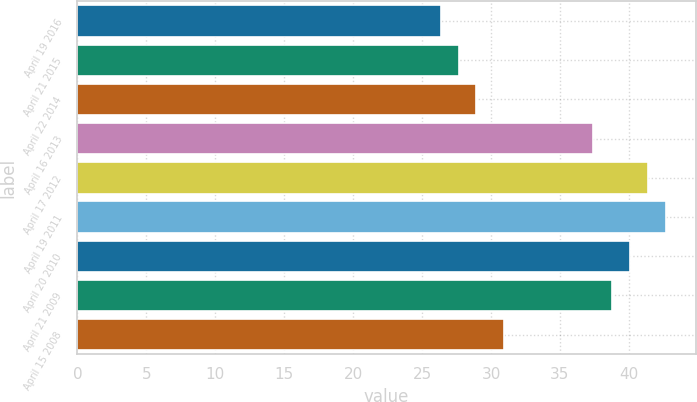Convert chart to OTSL. <chart><loc_0><loc_0><loc_500><loc_500><bar_chart><fcel>April 19 2016<fcel>April 21 2015<fcel>April 22 2014<fcel>April 16 2013<fcel>April 17 2012<fcel>April 19 2011<fcel>April 20 2010<fcel>April 21 2009<fcel>April 15 2008<nl><fcel>26.34<fcel>27.64<fcel>28.94<fcel>37.42<fcel>41.4<fcel>42.7<fcel>40.1<fcel>38.8<fcel>30.93<nl></chart> 